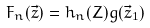Convert formula to latex. <formula><loc_0><loc_0><loc_500><loc_500>F _ { n } ( \vec { z } ) = h _ { n } ( Z ) g ( \vec { z } _ { 1 } )</formula> 